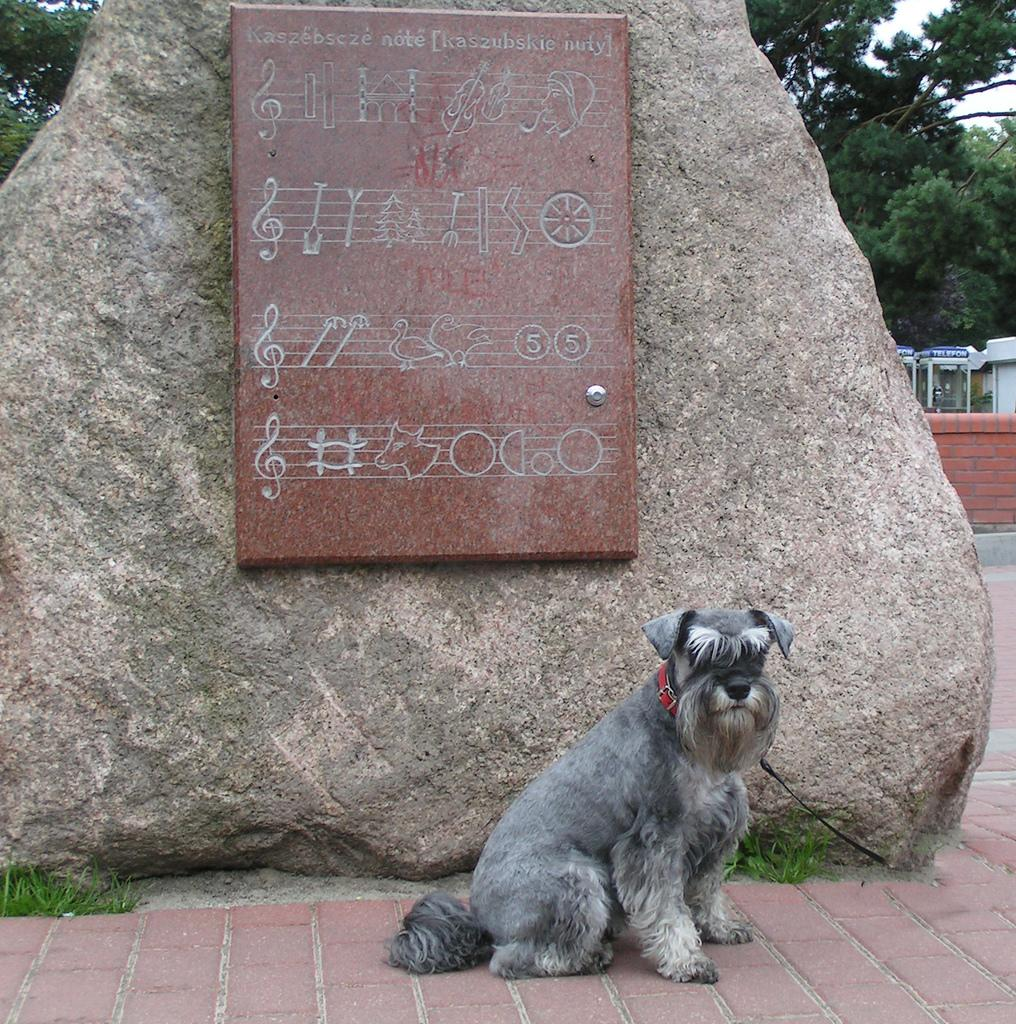What animal is sitting on the path in the image? There is a dog sitting on the path in the image. What is located behind the dog? There is a rock and a board with images behind the dog. What can be seen in the background of the image? There is a building, a fencing wall, and trees in the background of the image. What type of brush is the dog using to paint the room in the image? There is no brush or room present in the image; it features a dog sitting on a path with a rock and a board with images behind it. 